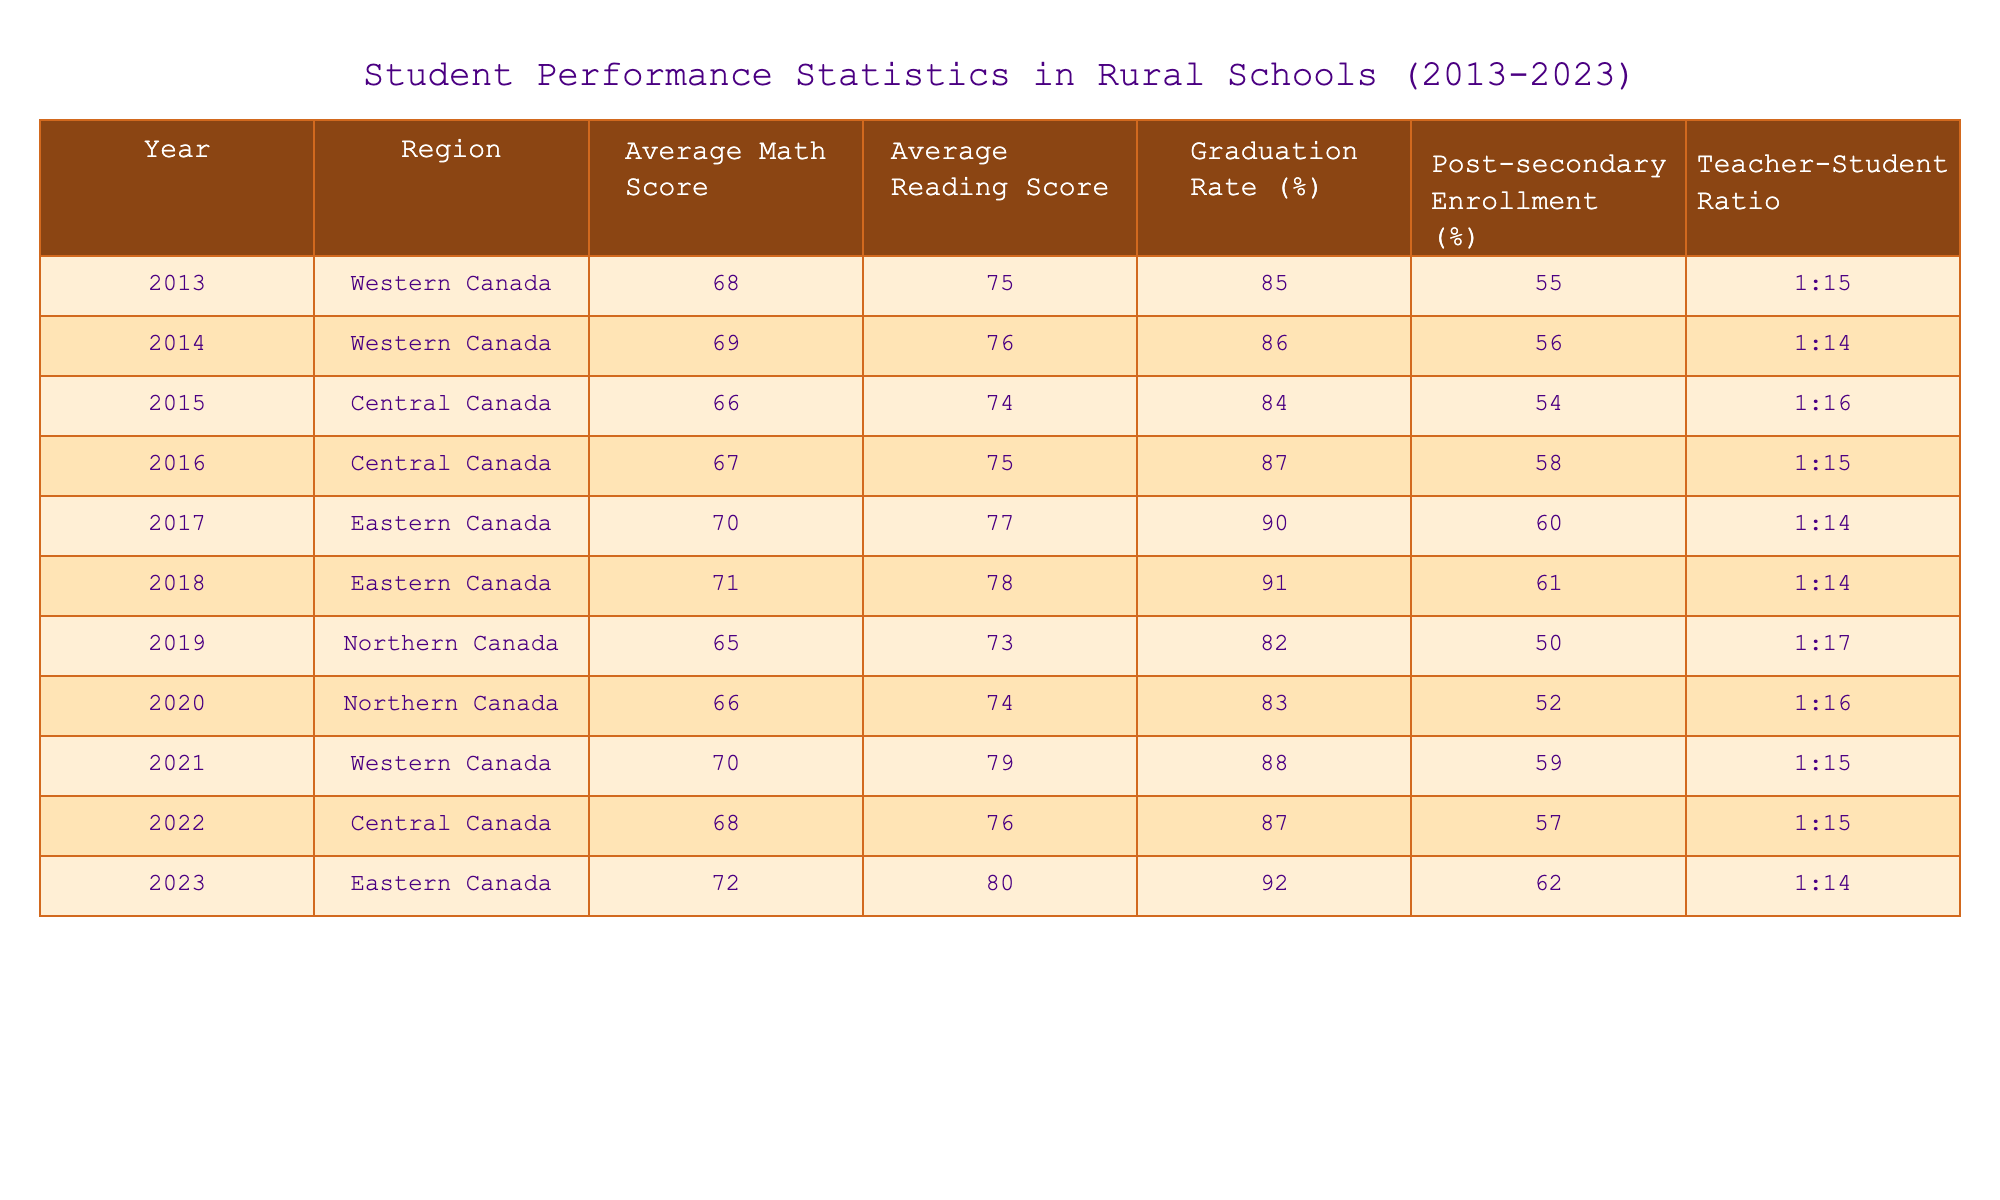What was the highest average math score recorded in the data? The table lists average math scores for each year and region. Scanning through the math scores, I see that the highest value is 72, which was recorded in 2023 for Eastern Canada.
Answer: 72 What is the graduation rate for Northern Canada in 2019? By looking at the table, the graduation rate specifically for Northern Canada in 2019 is listed directly as 82%.
Answer: 82% Which region had the lowest average reading score in 2015? The reading scores for that year show Central Canada with an average reading score of 74, which is the lowest score for that year across all regions listed.
Answer: 74 What was the change in the graduation rate from 2013 to 2023 in Eastern Canada? The graduation rate in Eastern Canada for 2013 is 85% and for 2023 it is 92%. The difference is calculated as 92 - 85 = 7%.
Answer: 7% Is the teacher-student ratio in 2014 better than in 2020? Comparing the teacher-student ratios, in 2014 it is 1:14 and in 2020 it is 1:16. Since a lower ratio indicates better conditions for students, yes, 2014 has a better ratio.
Answer: Yes What is the average post-secondary enrollment percentage for Central Canada over the years provided? The post-secondary enrollment percentages for Central Canada across the years are 54, 58, 57. Averaging these values gives (54 + 58 + 57)/3 = 56.33%.
Answer: 56.33% Which year had the highest average reading score, and what was the score? The highest average reading score across all years can be found by comparing the scores; in 2023, the average reading score reached 80, which is the highest.
Answer: 80 Did the average math score in Western Canada increase or decrease from 2014 to 2021? The average math scores for Western Canada are 69 in 2014 and 70 in 2021. Since 70 is greater than 69, it increased during this period.
Answer: Increased 